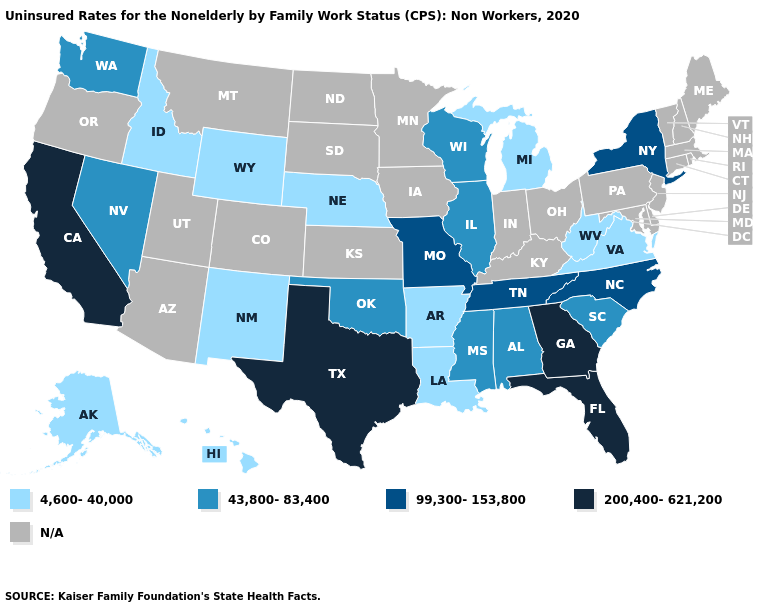What is the value of Wyoming?
Be succinct. 4,600-40,000. Name the states that have a value in the range N/A?
Keep it brief. Arizona, Colorado, Connecticut, Delaware, Indiana, Iowa, Kansas, Kentucky, Maine, Maryland, Massachusetts, Minnesota, Montana, New Hampshire, New Jersey, North Dakota, Ohio, Oregon, Pennsylvania, Rhode Island, South Dakota, Utah, Vermont. Which states hav the highest value in the MidWest?
Concise answer only. Missouri. What is the value of Georgia?
Give a very brief answer. 200,400-621,200. Name the states that have a value in the range 43,800-83,400?
Answer briefly. Alabama, Illinois, Mississippi, Nevada, Oklahoma, South Carolina, Washington, Wisconsin. Name the states that have a value in the range 43,800-83,400?
Short answer required. Alabama, Illinois, Mississippi, Nevada, Oklahoma, South Carolina, Washington, Wisconsin. How many symbols are there in the legend?
Quick response, please. 5. How many symbols are there in the legend?
Short answer required. 5. Name the states that have a value in the range 43,800-83,400?
Short answer required. Alabama, Illinois, Mississippi, Nevada, Oklahoma, South Carolina, Washington, Wisconsin. Does the map have missing data?
Keep it brief. Yes. What is the highest value in states that border Massachusetts?
Keep it brief. 99,300-153,800. Name the states that have a value in the range 99,300-153,800?
Quick response, please. Missouri, New York, North Carolina, Tennessee. What is the value of Louisiana?
Short answer required. 4,600-40,000. 